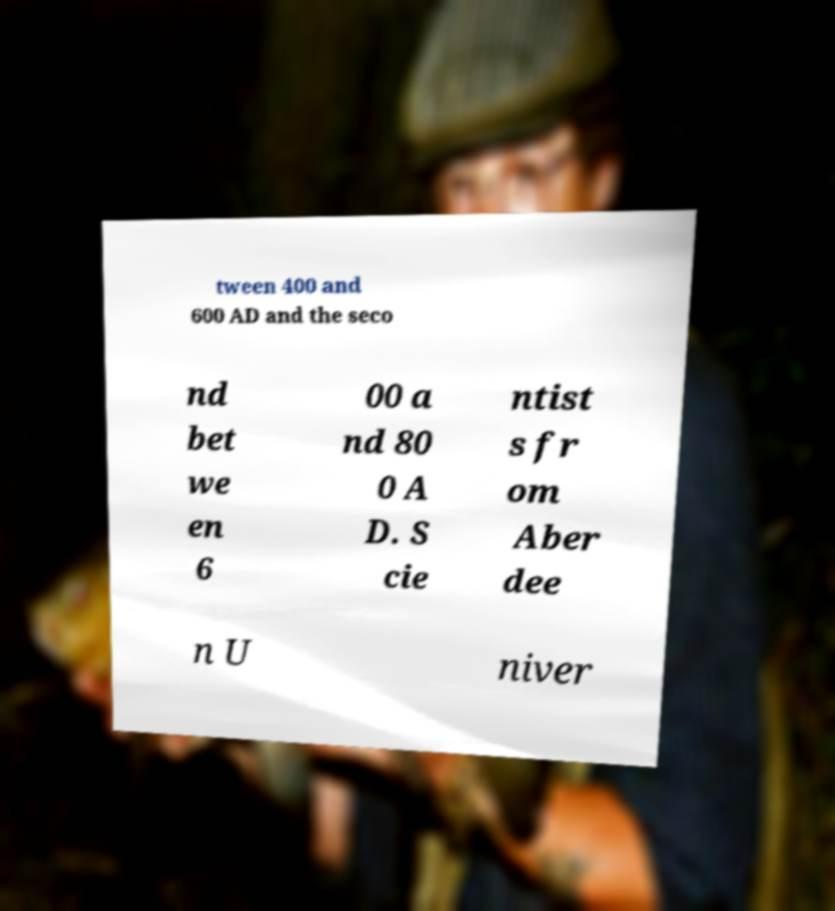Please identify and transcribe the text found in this image. tween 400 and 600 AD and the seco nd bet we en 6 00 a nd 80 0 A D. S cie ntist s fr om Aber dee n U niver 